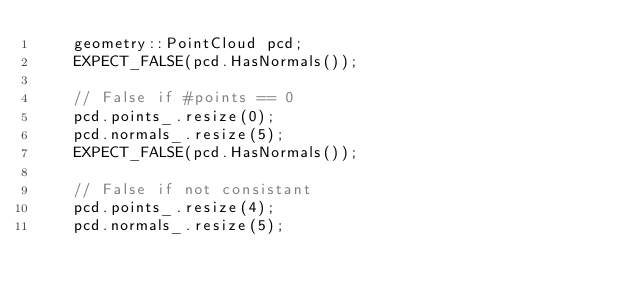<code> <loc_0><loc_0><loc_500><loc_500><_C++_>    geometry::PointCloud pcd;
    EXPECT_FALSE(pcd.HasNormals());

    // False if #points == 0
    pcd.points_.resize(0);
    pcd.normals_.resize(5);
    EXPECT_FALSE(pcd.HasNormals());

    // False if not consistant
    pcd.points_.resize(4);
    pcd.normals_.resize(5);</code> 